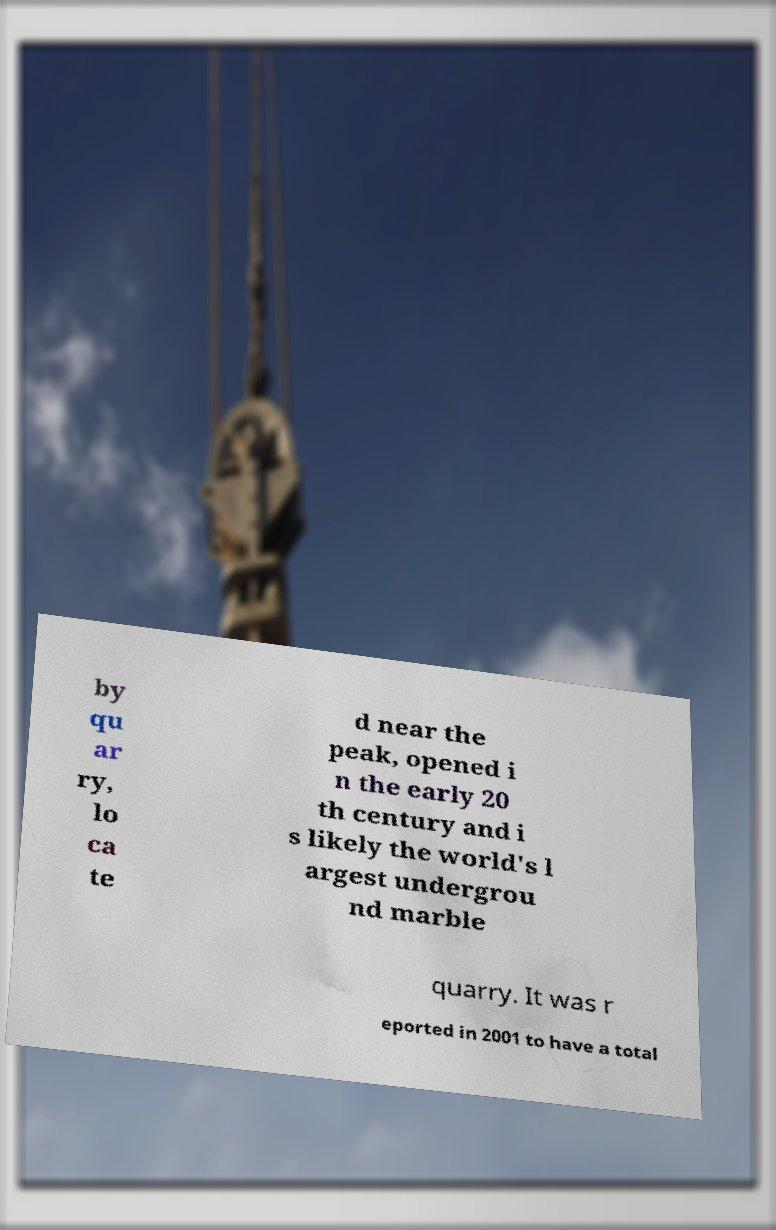What messages or text are displayed in this image? I need them in a readable, typed format. by qu ar ry, lo ca te d near the peak, opened i n the early 20 th century and i s likely the world's l argest undergrou nd marble quarry. It was r eported in 2001 to have a total 